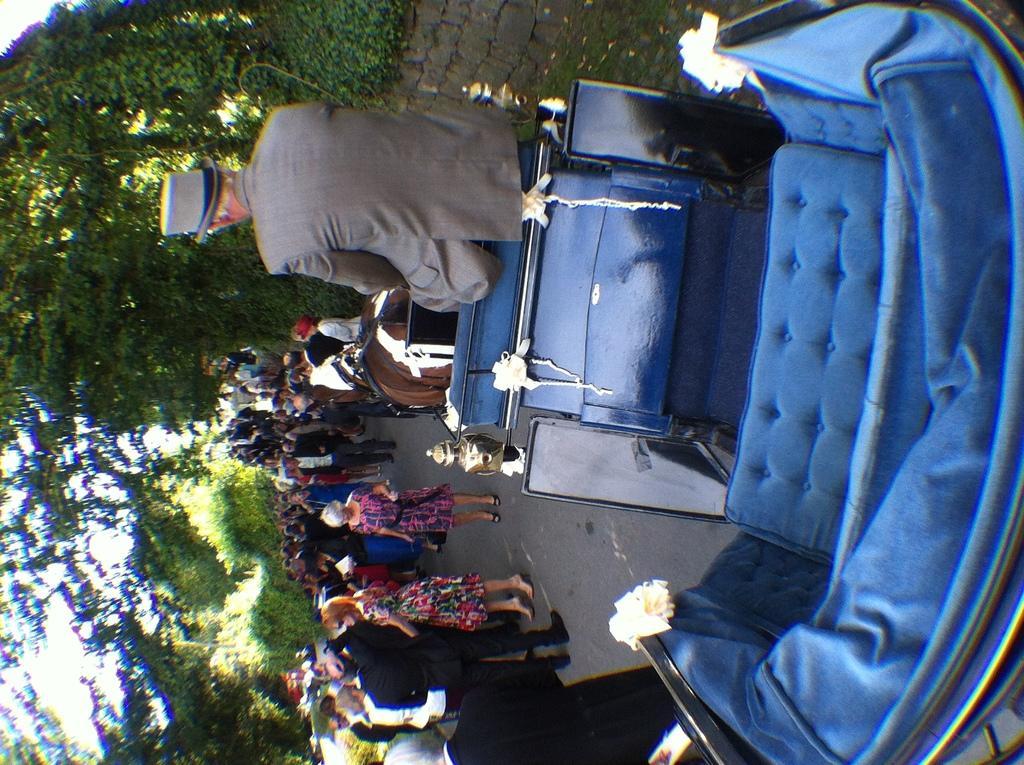Can you describe this image briefly? In this image I can see the blue color cart. I can see one person sitting on the cart. To the side of the cart I can see the group of people with different color dresses. In the background I can see many trees and the sky. 